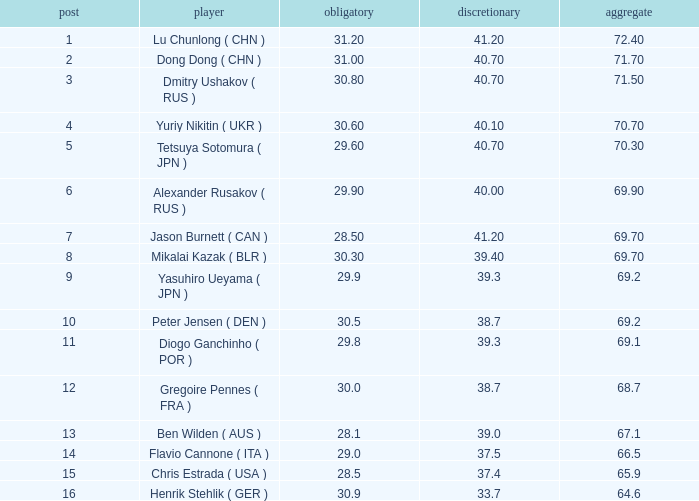What's the total of the position of 1? None. 